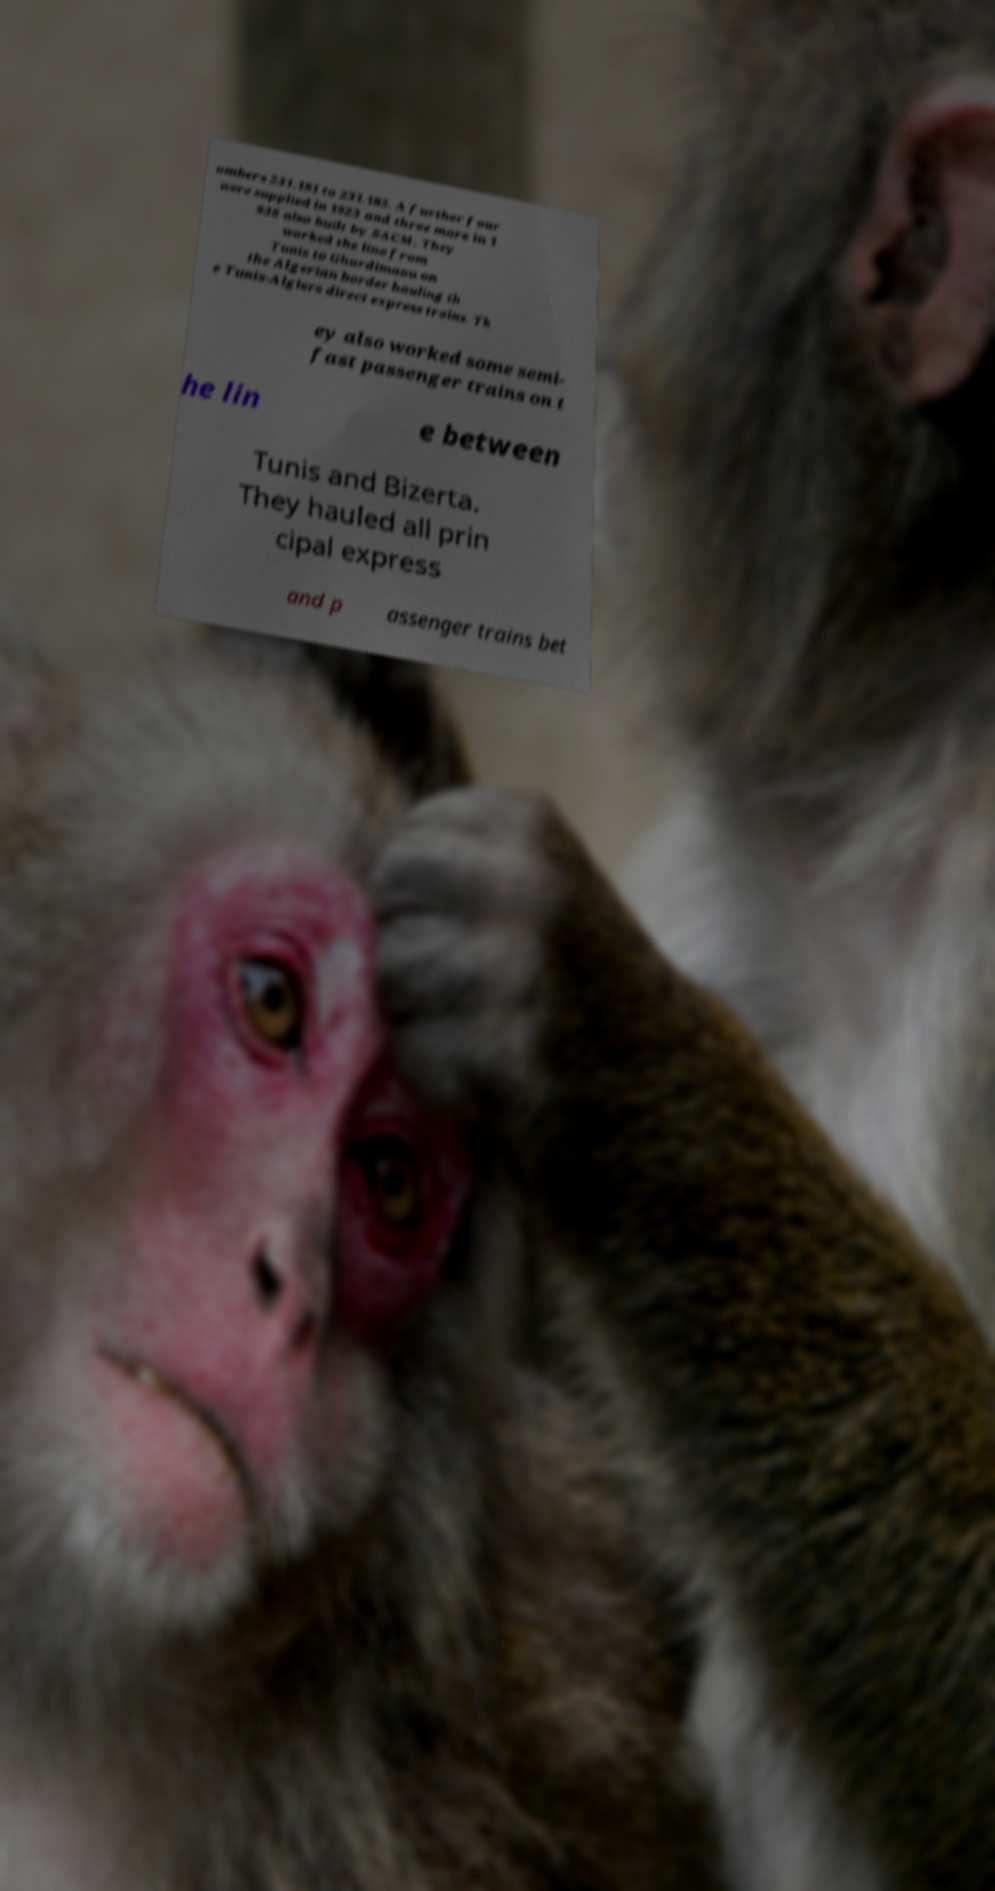Please read and relay the text visible in this image. What does it say? umbers 231.181 to 231.185. A further four were supplied in 1923 and three more in 1 938 also built by SACM. They worked the line from Tunis to Ghardimaou on the Algerian border hauling th e Tunis-Algiers direct express trains. Th ey also worked some semi- fast passenger trains on t he lin e between Tunis and Bizerta. They hauled all prin cipal express and p assenger trains bet 